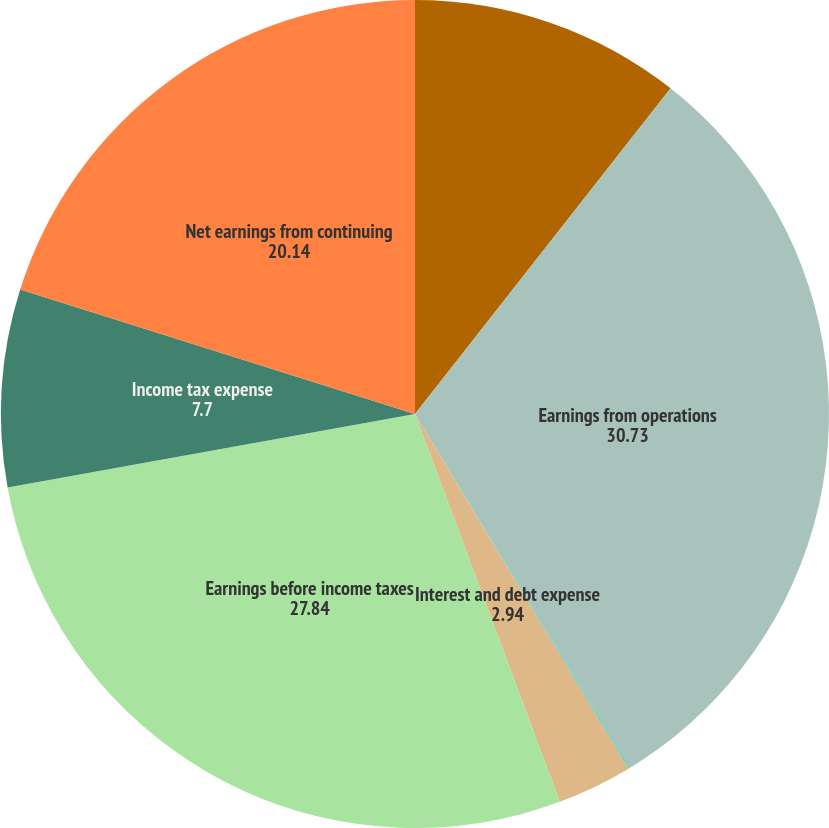<chart> <loc_0><loc_0><loc_500><loc_500><pie_chart><fcel>(Dollars in millions) Years<fcel>Earnings from operations<fcel>Other income/(loss) net<fcel>Interest and debt expense<fcel>Earnings before income taxes<fcel>Income tax expense<fcel>Net earnings from continuing<nl><fcel>10.59%<fcel>30.73%<fcel>0.05%<fcel>2.94%<fcel>27.84%<fcel>7.7%<fcel>20.14%<nl></chart> 